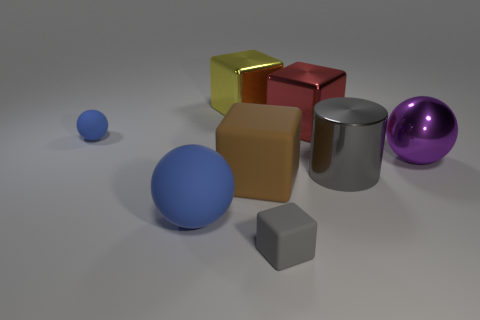There is a blue thing that is right of the tiny thing that is to the left of the shiny thing behind the red thing; what shape is it?
Make the answer very short. Sphere. How many large yellow cubes are right of the metal sphere right of the tiny rubber cube?
Make the answer very short. 0. Is the small gray thing made of the same material as the large yellow block?
Your answer should be compact. No. There is a ball on the right side of the big metal cube to the right of the yellow metal block; what number of balls are in front of it?
Provide a short and direct response. 1. There is a big ball that is on the right side of the large matte cube; what color is it?
Your answer should be compact. Purple. There is a big metal thing that is to the left of the large metal block to the right of the gray rubber thing; what is its shape?
Ensure brevity in your answer.  Cube. Is the small matte block the same color as the cylinder?
Give a very brief answer. Yes. How many cylinders are tiny things or small gray objects?
Keep it short and to the point. 0. There is a large cube that is both behind the large metallic cylinder and left of the tiny matte cube; what is it made of?
Offer a terse response. Metal. How many small blue matte objects are on the right side of the tiny blue object?
Give a very brief answer. 0. 